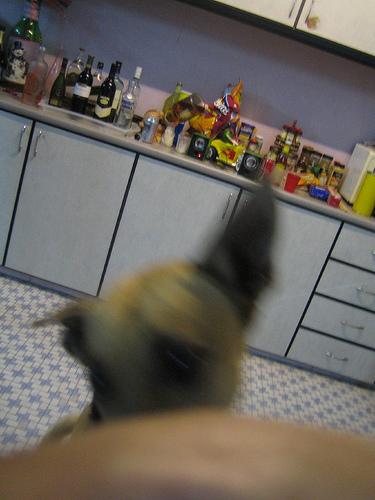IS there a dog in the picture?
Keep it brief. Yes. What color is the bottle?
Concise answer only. Black. What is the puppy looking at?
Concise answer only. Camera. How many cats do you see?
Concise answer only. 0. What is the animal in her person's hand?
Be succinct. Dog. What sound does the animal make when it's happy?
Write a very short answer. Bark. What breed is the dog?
Keep it brief. Chihuahua. What type of dog is this?
Short answer required. Chihuahua. Is there food on the counter?
Be succinct. Yes. What color is the animal?
Quick response, please. Brown. What color is the dog?
Give a very brief answer. Brown. Is this dog feeling playful?
Write a very short answer. Yes. What is in the background?
Short answer required. Counter. What is around the dog's neck?
Concise answer only. Collar. What bird is this?
Be succinct. None. What is the dog doing?
Short answer required. Jumping. Does this animal meow or bark?
Answer briefly. Bark. How many dogs are in the picture?
Be succinct. 1. What animal is this?
Keep it brief. Dog. What kind of animal is this?
Concise answer only. Dog. What is the dog looking at?
Answer briefly. Food. Where is the dog?
Write a very short answer. Kitchen. How many bottles are on the sink?
Be succinct. 5. What color bow is on the dog?
Concise answer only. None. What is the dog inside of?
Concise answer only. Kitchen. Would it be a good idea to eat chips here?
Short answer required. Yes. What is this dog doing?
Short answer required. Tilting its head. Which animal is this?
Concise answer only. Dog. Is the counter clean or messy?
Give a very brief answer. Messy. What is this animal?
Keep it brief. Dog. What animal is in the picture?
Answer briefly. Dog. What animal is shown?
Quick response, please. Dog. What is the cat slapping?
Write a very short answer. Person. 